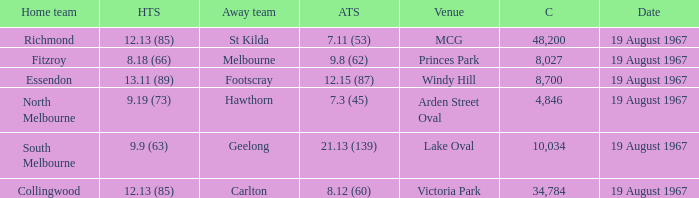If the away team scored 7.3 (45), what was the home team score? 9.19 (73). 